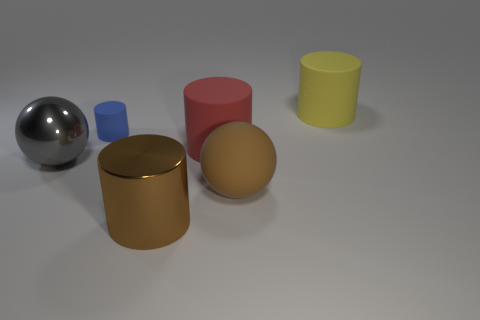Is there any other thing that is the same size as the blue cylinder?
Your answer should be very brief. No. There is a red cylinder; how many brown metal things are behind it?
Your response must be concise. 0. Is there another big red matte thing that has the same shape as the large red thing?
Make the answer very short. No. Do the red object and the big brown object that is behind the big brown cylinder have the same shape?
Offer a terse response. No. What number of cylinders are tiny metal things or big red objects?
Ensure brevity in your answer.  1. There is a object that is behind the small blue object; what is its shape?
Offer a very short reply. Cylinder. How many small brown cylinders are the same material as the big gray object?
Your answer should be compact. 0. Is the number of big red cylinders behind the blue matte cylinder less than the number of gray metal cylinders?
Ensure brevity in your answer.  No. How big is the metal thing in front of the large object that is on the left side of the tiny matte thing?
Keep it short and to the point. Large. Does the small cylinder have the same color as the large rubber cylinder that is left of the large brown rubber thing?
Give a very brief answer. No. 